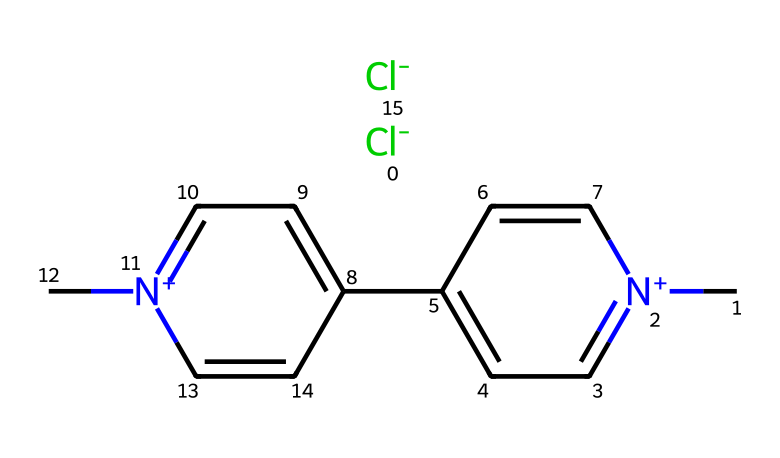What is the main active element present in paraquat? The chemical structure of paraquat shows two chlorine atoms indicated by the [Cl-] parts in the SMILES notation. Chlorine is the primary element in its structure.
Answer: chlorine How many carbon atoms are in paraquat? Counting the carbon atoms represented in the structure from the SMILES notation (C and the chain of cc), there are a total of 8 carbon atoms.
Answer: eight What type of chemical is paraquat classified as? Paraquat is classified as a herbicide due to its function as a chemical for controlling weeds and other unwanted plants.
Answer: herbicide Does paraquat contain any nitrogen atoms? The structure includes two nitrogen atoms indicated by the [n+] parts in the chemical representation, confirming the presence of nitrogen.
Answer: yes What can be inferred about the polarity of paraquat based on its structure? The structure contains highly polar functional groups, including nitrogen and chlorine, suggesting that paraquat is likely a polar compound, impacting its solubility and biological activity.
Answer: polar How does the presence of chlorine influence the toxicity of paraquat? The presence of chlorine increases the herbicide's reactivity and toxicity, as chlorine attracts electrons, leading to enhanced interaction with biological molecules, contributing to its high toxicity.
Answer: increases toxicity What is the significance of the two nitrogen atoms in the structure of paraquat? The two nitrogen atoms in paraquat contribute to its ionic characteristics, increasing solubility in water and potential interactions with biological receptors, enhancing its herbicidal properties.
Answer: enhance herbicidal properties 